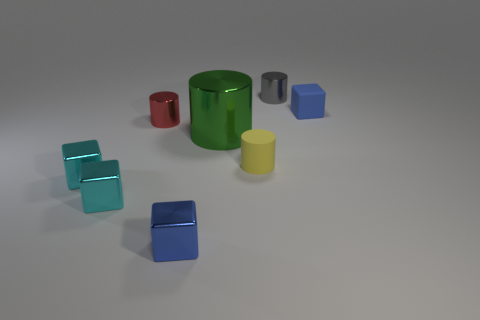Subtract all metal cylinders. How many cylinders are left? 1 Add 2 matte things. How many objects exist? 10 Subtract 1 blocks. How many blocks are left? 3 Subtract all green cylinders. How many cyan blocks are left? 2 Subtract all red cylinders. How many cylinders are left? 3 Subtract all big cylinders. Subtract all big objects. How many objects are left? 6 Add 4 tiny cyan objects. How many tiny cyan objects are left? 6 Add 4 tiny cylinders. How many tiny cylinders exist? 7 Subtract 0 red cubes. How many objects are left? 8 Subtract all gray blocks. Subtract all brown spheres. How many blocks are left? 4 